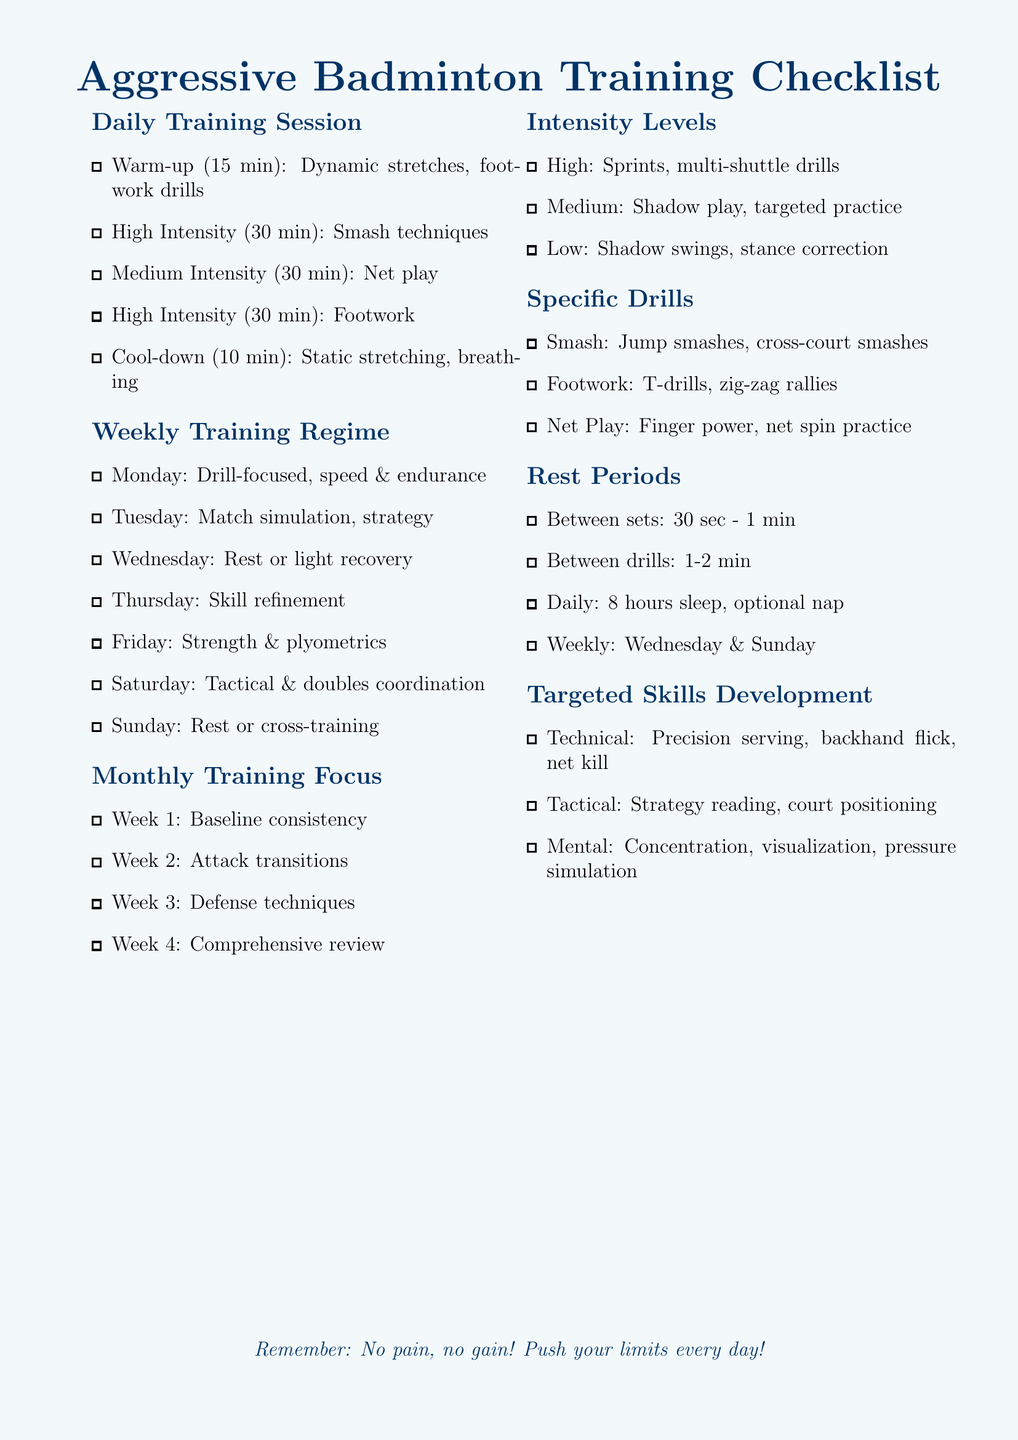What is the duration of the warm-up? The warm-up, as listed in the daily training session, lasts for 15 minutes.
Answer: 15 min Which day is designated for rest or light recovery? The weekly training regime specifies that Wednesday is a rest or light recovery day.
Answer: Wednesday What specific skill is focused on in Week 2 of the monthly training? Week 2 of the monthly training focus is centered on attack transitions.
Answer: Attack transitions How long should daily rest periods include sleep? The daily rest period suggests including 8 hours of sleep.
Answer: 8 hours What is the main high-intensity drill mentioned? The high-intensity drill specified in the intensity levels section is sprints.
Answer: Sprints Which day of the week includes tactical and doubles coordination? Saturday is mentioned in the weekly training regime for tactical and doubles coordination.
Answer: Saturday What type of practice is categorized as medium intensity? Targeted practice is identified as medium-intensity activity in the intensity levels.
Answer: Targeted practice Which drill focus includes precision serving? Precision serving is part of the targeted skills development regarding technical skills.
Answer: Technical What is the primary emphasis for Friday training sessions? The primary emphasis for Friday training sessions is on strength and plyometrics.
Answer: Strength & plyometrics 